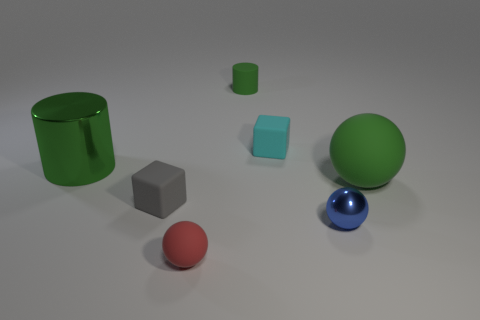How many things are either large green balls or rubber spheres?
Your response must be concise. 2. There is a small blue thing; does it have the same shape as the large object that is on the right side of the green metal thing?
Provide a short and direct response. Yes. What is the shape of the big object behind the large green rubber object?
Ensure brevity in your answer.  Cylinder. Is the shape of the small gray matte object the same as the blue thing?
Provide a succinct answer. No. What is the size of the other matte object that is the same shape as the tiny gray thing?
Provide a short and direct response. Small. Does the matte cube behind the green shiny cylinder have the same size as the small gray block?
Make the answer very short. Yes. There is a thing that is both on the left side of the small red object and right of the green metal cylinder; what size is it?
Give a very brief answer. Small. There is another cylinder that is the same color as the tiny rubber cylinder; what is its material?
Offer a terse response. Metal. How many large rubber balls are the same color as the small matte cylinder?
Your answer should be very brief. 1. Is the number of matte cubes behind the green rubber cylinder the same as the number of big shiny cylinders?
Provide a succinct answer. No. 